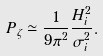<formula> <loc_0><loc_0><loc_500><loc_500>P _ { \zeta } \simeq \frac { 1 } { 9 \pi ^ { 2 } } \frac { H _ { i } ^ { 2 } } { \sigma _ { i } ^ { 2 } } .</formula> 